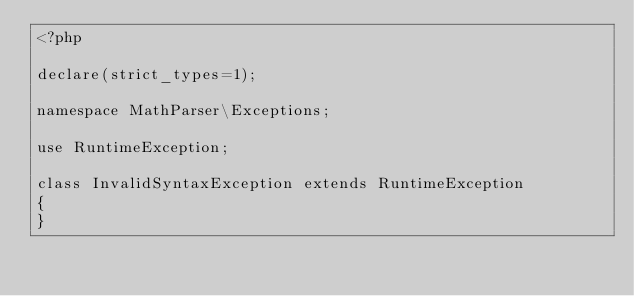<code> <loc_0><loc_0><loc_500><loc_500><_PHP_><?php

declare(strict_types=1);

namespace MathParser\Exceptions;

use RuntimeException;

class InvalidSyntaxException extends RuntimeException
{
}</code> 